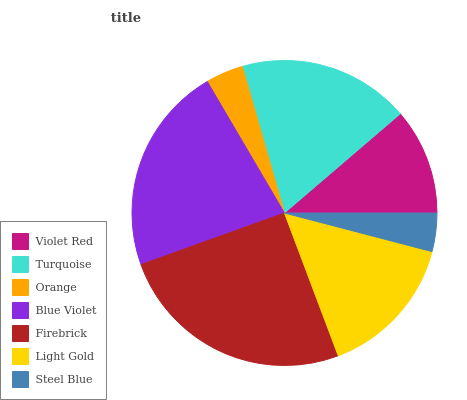Is Orange the minimum?
Answer yes or no. Yes. Is Firebrick the maximum?
Answer yes or no. Yes. Is Turquoise the minimum?
Answer yes or no. No. Is Turquoise the maximum?
Answer yes or no. No. Is Turquoise greater than Violet Red?
Answer yes or no. Yes. Is Violet Red less than Turquoise?
Answer yes or no. Yes. Is Violet Red greater than Turquoise?
Answer yes or no. No. Is Turquoise less than Violet Red?
Answer yes or no. No. Is Light Gold the high median?
Answer yes or no. Yes. Is Light Gold the low median?
Answer yes or no. Yes. Is Steel Blue the high median?
Answer yes or no. No. Is Orange the low median?
Answer yes or no. No. 